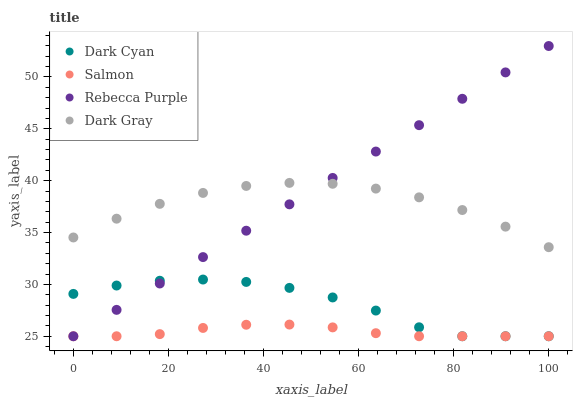Does Salmon have the minimum area under the curve?
Answer yes or no. Yes. Does Rebecca Purple have the maximum area under the curve?
Answer yes or no. Yes. Does Dark Gray have the minimum area under the curve?
Answer yes or no. No. Does Dark Gray have the maximum area under the curve?
Answer yes or no. No. Is Rebecca Purple the smoothest?
Answer yes or no. Yes. Is Dark Cyan the roughest?
Answer yes or no. Yes. Is Dark Gray the smoothest?
Answer yes or no. No. Is Dark Gray the roughest?
Answer yes or no. No. Does Dark Cyan have the lowest value?
Answer yes or no. Yes. Does Dark Gray have the lowest value?
Answer yes or no. No. Does Rebecca Purple have the highest value?
Answer yes or no. Yes. Does Dark Gray have the highest value?
Answer yes or no. No. Is Salmon less than Dark Gray?
Answer yes or no. Yes. Is Dark Gray greater than Dark Cyan?
Answer yes or no. Yes. Does Salmon intersect Rebecca Purple?
Answer yes or no. Yes. Is Salmon less than Rebecca Purple?
Answer yes or no. No. Is Salmon greater than Rebecca Purple?
Answer yes or no. No. Does Salmon intersect Dark Gray?
Answer yes or no. No. 